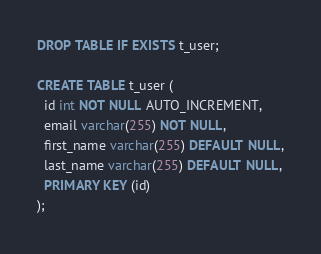Convert code to text. <code><loc_0><loc_0><loc_500><loc_500><_SQL_>DROP TABLE IF EXISTS t_user;

CREATE TABLE t_user (
  id int NOT NULL AUTO_INCREMENT,
  email varchar(255) NOT NULL,
  first_name varchar(255) DEFAULT NULL,
  last_name varchar(255) DEFAULT NULL,
  PRIMARY KEY (id)
);</code> 